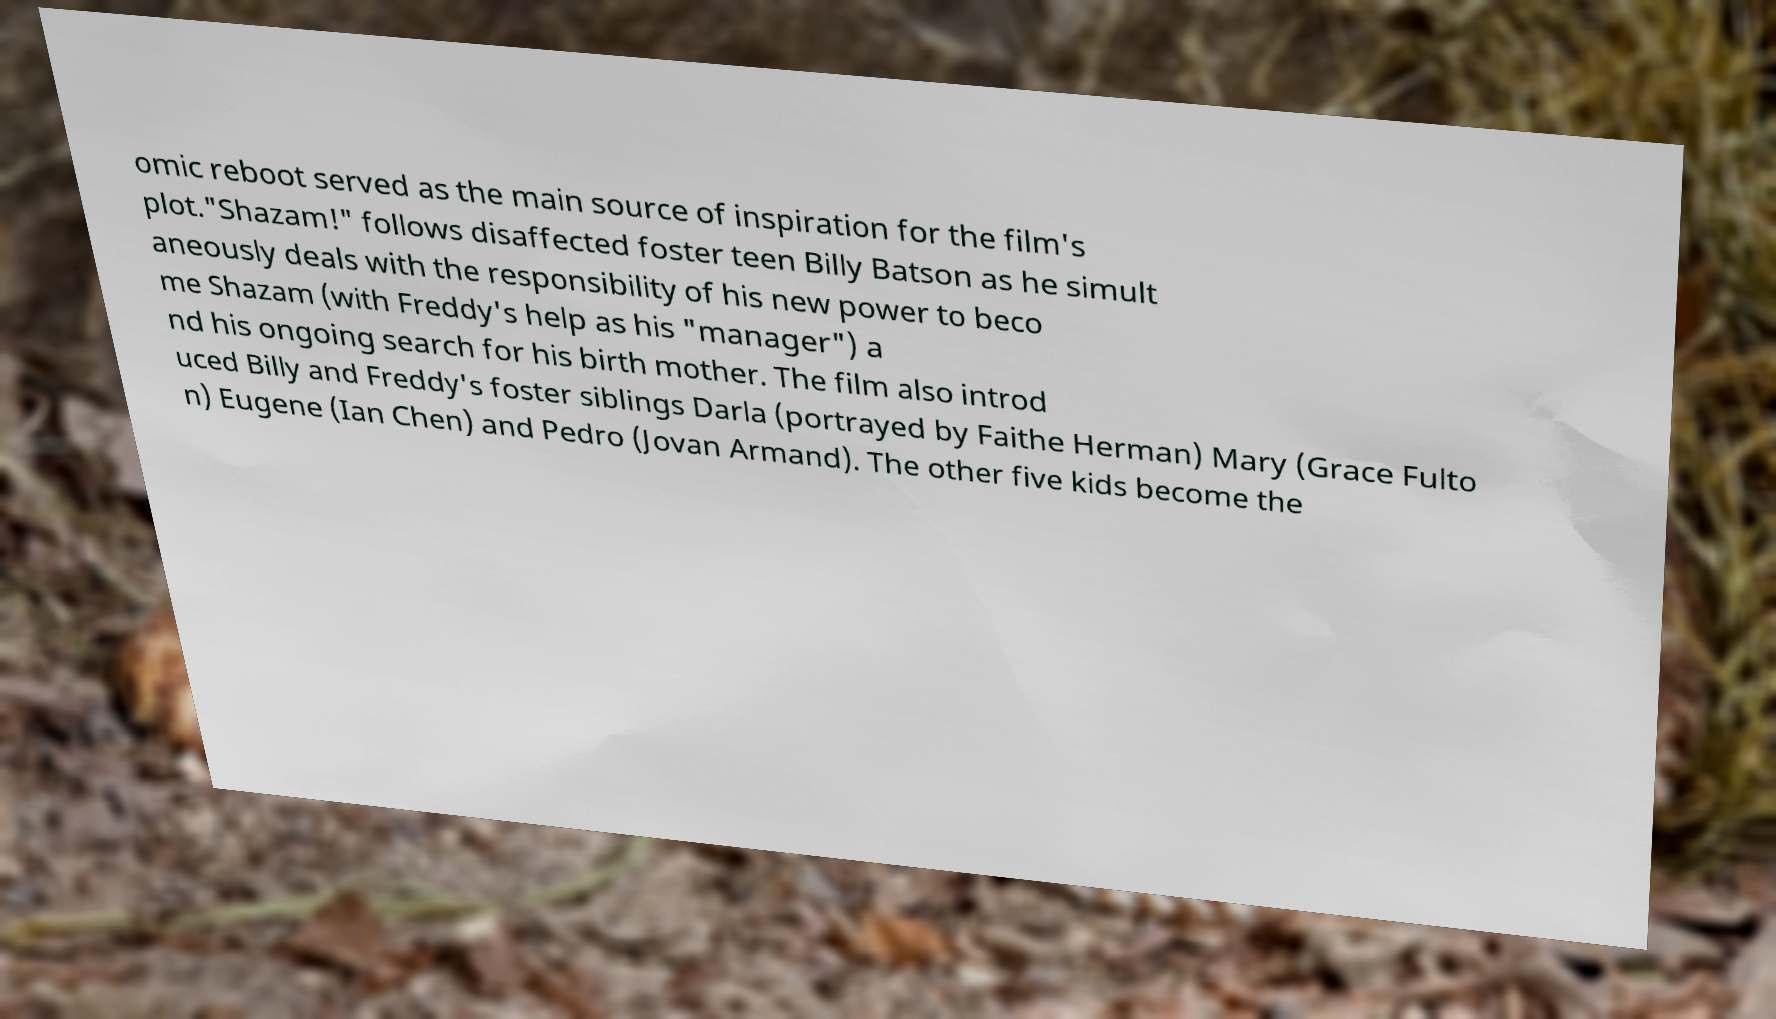Can you accurately transcribe the text from the provided image for me? omic reboot served as the main source of inspiration for the film's plot."Shazam!" follows disaffected foster teen Billy Batson as he simult aneously deals with the responsibility of his new power to beco me Shazam (with Freddy's help as his "manager") a nd his ongoing search for his birth mother. The film also introd uced Billy and Freddy's foster siblings Darla (portrayed by Faithe Herman) Mary (Grace Fulto n) Eugene (Ian Chen) and Pedro (Jovan Armand). The other five kids become the 